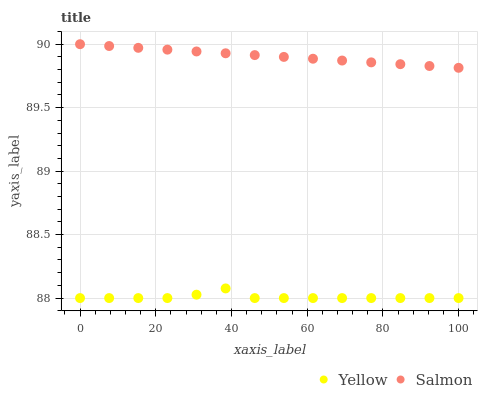Does Yellow have the minimum area under the curve?
Answer yes or no. Yes. Does Salmon have the maximum area under the curve?
Answer yes or no. Yes. Does Yellow have the maximum area under the curve?
Answer yes or no. No. Is Salmon the smoothest?
Answer yes or no. Yes. Is Yellow the roughest?
Answer yes or no. Yes. Is Yellow the smoothest?
Answer yes or no. No. Does Yellow have the lowest value?
Answer yes or no. Yes. Does Salmon have the highest value?
Answer yes or no. Yes. Does Yellow have the highest value?
Answer yes or no. No. Is Yellow less than Salmon?
Answer yes or no. Yes. Is Salmon greater than Yellow?
Answer yes or no. Yes. Does Yellow intersect Salmon?
Answer yes or no. No. 